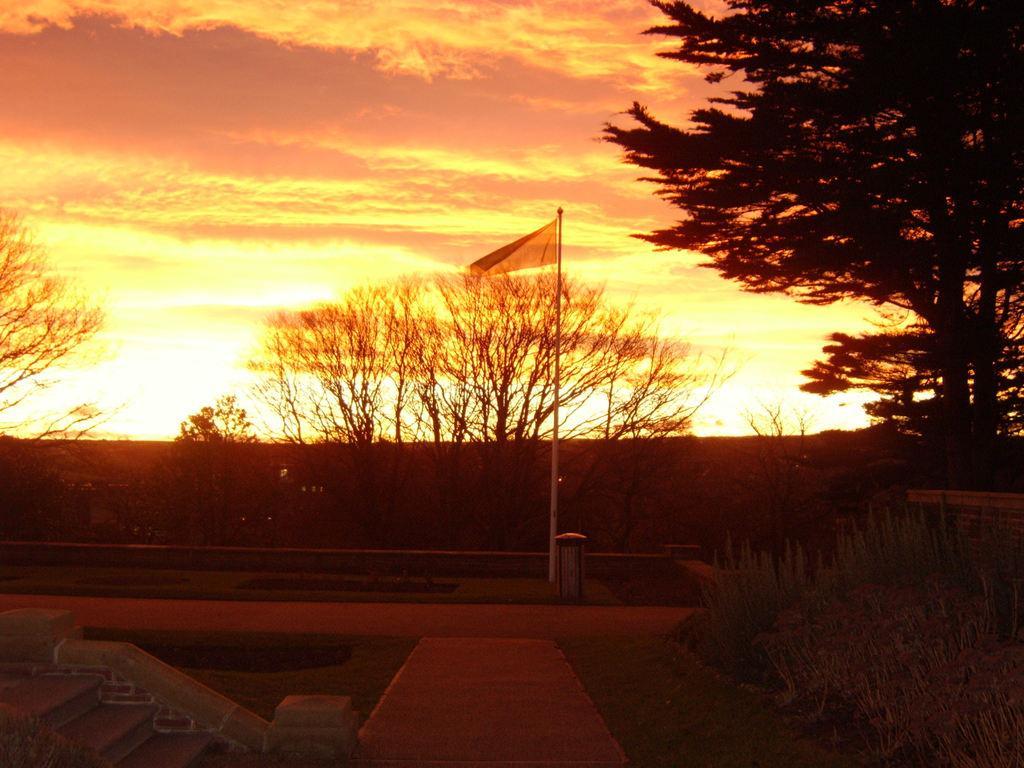Describe this image in one or two sentences. In this image we can see the flag to a pole. We can also see the staircase, pathway, some plants, grass, a group of trees and the sky which looks cloudy. 